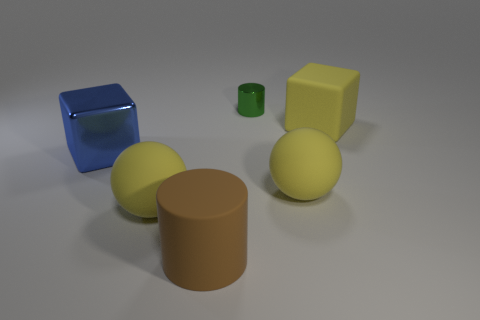Add 2 yellow objects. How many objects exist? 8 Subtract all cubes. How many objects are left? 4 Add 3 big yellow matte blocks. How many big yellow matte blocks are left? 4 Add 1 big things. How many big things exist? 6 Subtract 0 gray spheres. How many objects are left? 6 Subtract all large yellow rubber spheres. Subtract all metallic cylinders. How many objects are left? 3 